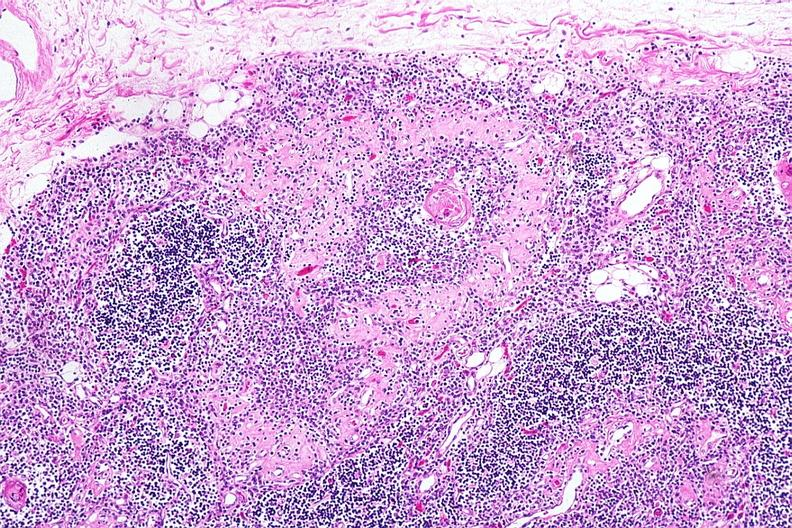does multiple myeloma show hassalls corpuscle with fibrosis in periphery of surrounding lymphoid follicle lesion?
Answer the question using a single word or phrase. No 